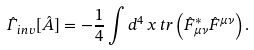Convert formula to latex. <formula><loc_0><loc_0><loc_500><loc_500>\hat { \Gamma } _ { i n v } [ \hat { A } ] = - { \frac { 1 } { 4 } } \int d ^ { 4 } \, x \, t r \left ( \hat { F } _ { \mu \nu } ^ { * } \hat { F } ^ { \mu \nu } \right ) .</formula> 